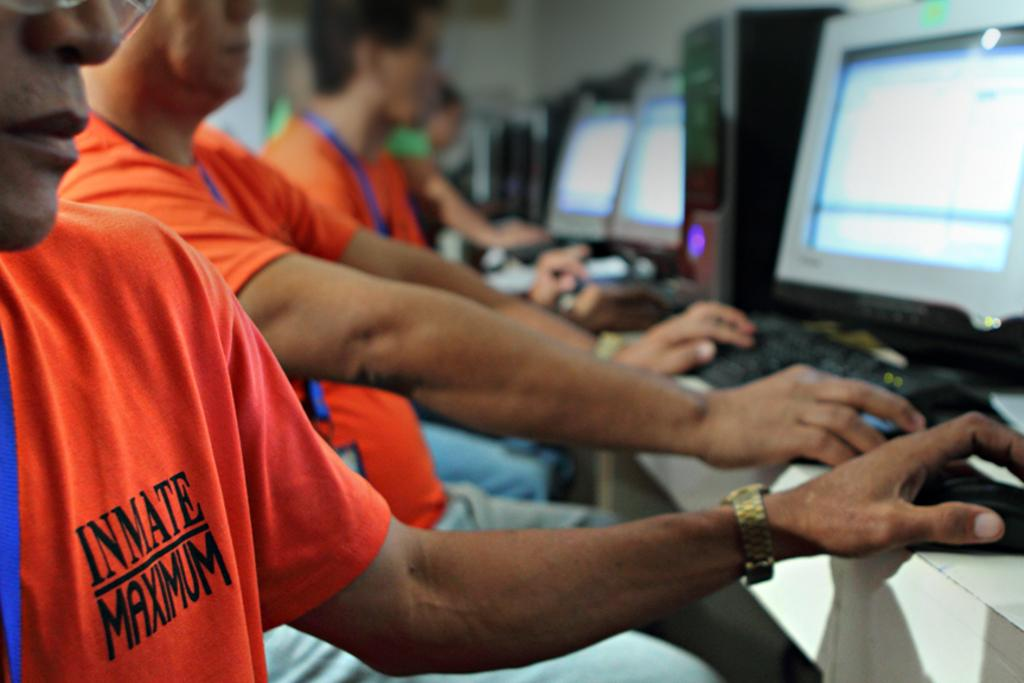<image>
Offer a succinct explanation of the picture presented. Man wearing an orange shirt that says Inmate Maximum using computer. 